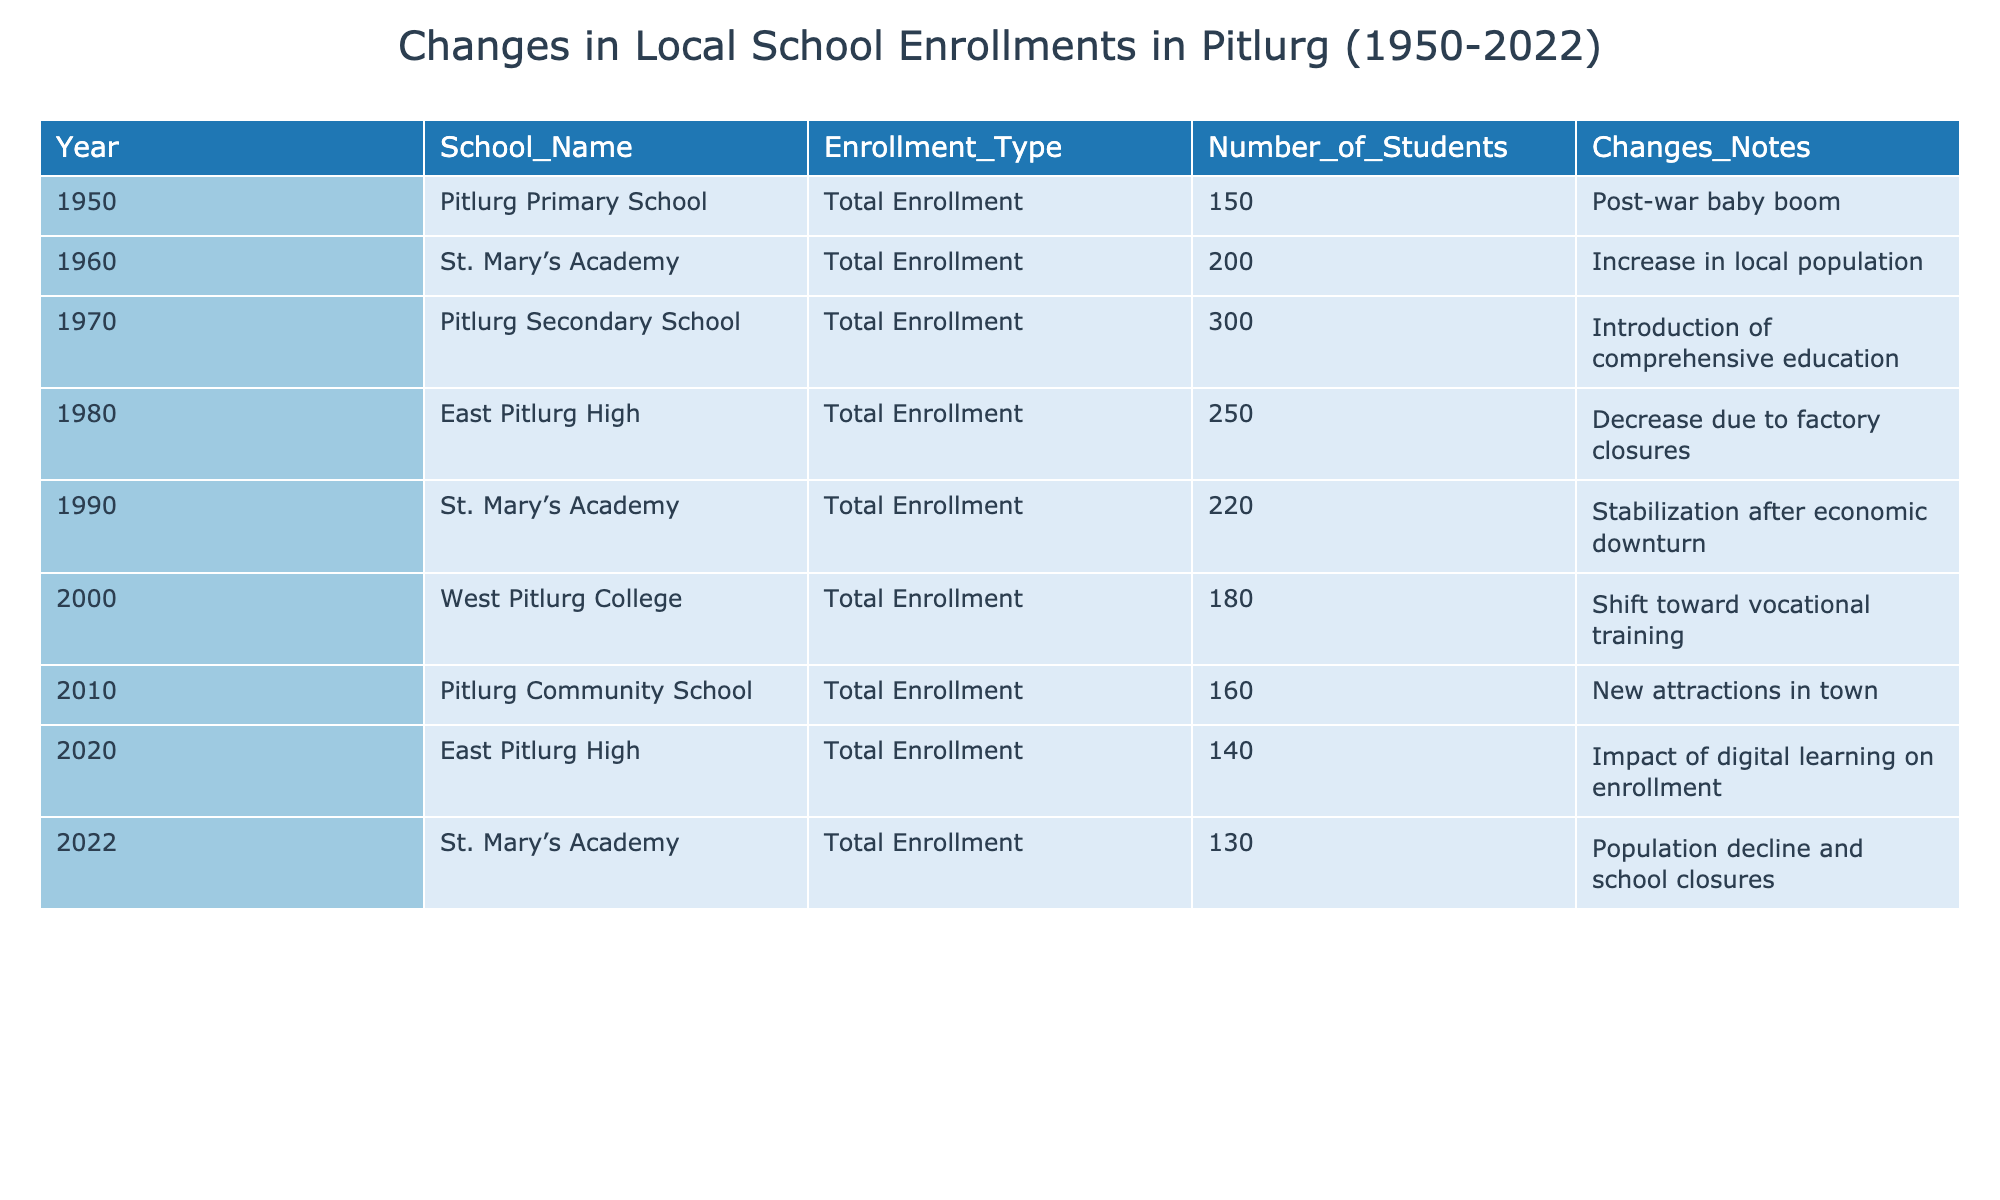What was the total enrollment at Pitlurg Primary School in 1950? The table shows that the enrollment at Pitlurg Primary School in 1950 was 150 students.
Answer: 150 Which school had the highest enrollment in 1970? In 1970, the enrollment at Pitlurg Secondary School was 300 students, which is the highest among all listed schools for that year.
Answer: Pitlurg Secondary School What was the enrollment change at East Pitlurg High from 2010 to 2020? East Pitlurg High had an enrollment of 160 students in 2010 and 140 students in 2020. The change is a decrease of 20 students (160 - 140).
Answer: Decrease of 20 students How many students were enrolled at St. Mary’s Academy in 1990? The table indicates that St. Mary’s Academy had an enrollment of 220 students in 1990.
Answer: 220 Was there an increase or decrease in total enrollment from 2000 to 2010 in Pitlurg Community School? In 2000, West Pitlurg College had an enrollment of 180 students, while in 2010, Pitlurg Community School had an enrollment of 160 students. This indicates a decrease of 20 students (180 - 160).
Answer: Decrease What was the overall trend in student enrollment from 1950 to 2022? By examining the data, we can see a decreasing trend in total enrollment overall, with peaks in the 1970s followed by a steady decline, particularly noted in the later years up to 2022.
Answer: Decreasing trend If we average the total enrollment numbers from 1950 to 2022, what do we get? The total enrollments from 1950 to 2022 are 150, 200, 300, 250, 220, 180, 160, 140, and 130. Summing them gives 1680, and there are 9 data points, so the average is 1680/9 = approximately 186.67.
Answer: Approximately 186.67 Did all the schools have increasing enrollments over the years? By reviewing the enrollment numbers, we can see that not all schools experienced increases; for instance, St. Mary’s Academy decreased from 200 in 1960 to 130 in 2022, indicating that not all schools had increasing enrollments.
Answer: No Which school saw the lowest enrollment in 2022? The table reveals that in 2022, St. Mary’s Academy had the lowest enrollment with 130 students compared to other schools.
Answer: St. Mary's Academy What were the enrollment numbers for East Pitlurg High during the years provided? The enrollment numbers for East Pitlurg High were 250 in 1980 and 140 in 2020, showcasing a significant drop over the years.
Answer: 250 in 1980, 140 in 2020 How many schools had a total enrollment of over 200 students in 1960? The only school with an enrollment over 200 students in 1960 was St. Mary’s Academy with 200; none others are listed with enrollment over 200 during that year.
Answer: 1 school 